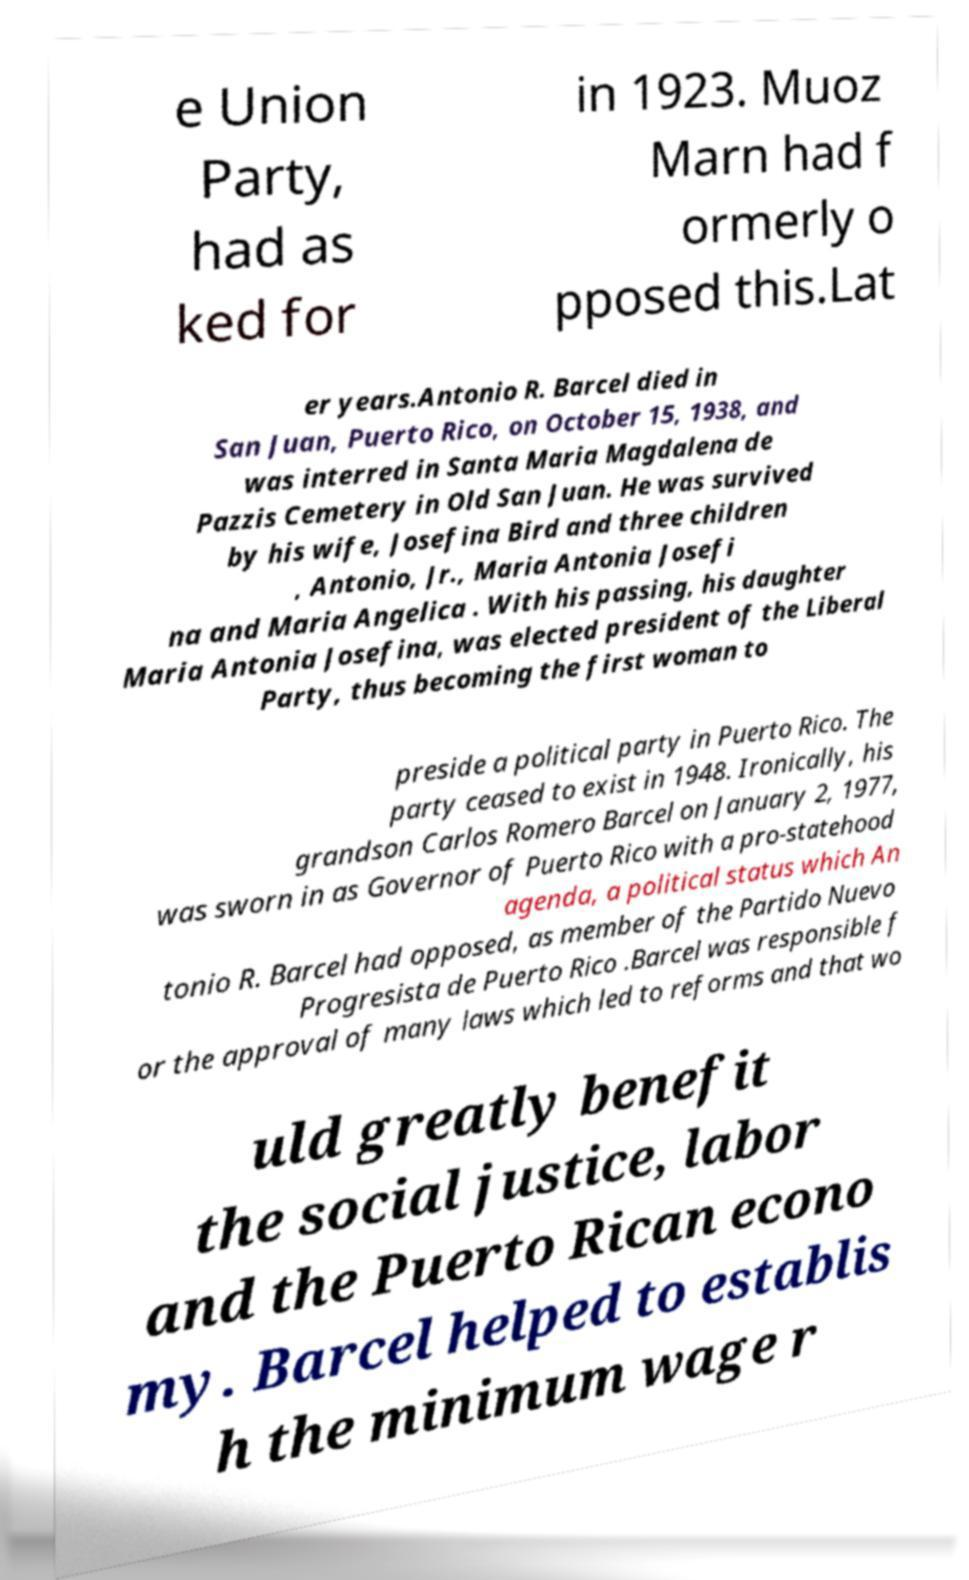Can you read and provide the text displayed in the image?This photo seems to have some interesting text. Can you extract and type it out for me? e Union Party, had as ked for in 1923. Muoz Marn had f ormerly o pposed this.Lat er years.Antonio R. Barcel died in San Juan, Puerto Rico, on October 15, 1938, and was interred in Santa Maria Magdalena de Pazzis Cemetery in Old San Juan. He was survived by his wife, Josefina Bird and three children , Antonio, Jr., Maria Antonia Josefi na and Maria Angelica . With his passing, his daughter Maria Antonia Josefina, was elected president of the Liberal Party, thus becoming the first woman to preside a political party in Puerto Rico. The party ceased to exist in 1948. Ironically, his grandson Carlos Romero Barcel on January 2, 1977, was sworn in as Governor of Puerto Rico with a pro-statehood agenda, a political status which An tonio R. Barcel had opposed, as member of the Partido Nuevo Progresista de Puerto Rico .Barcel was responsible f or the approval of many laws which led to reforms and that wo uld greatly benefit the social justice, labor and the Puerto Rican econo my. Barcel helped to establis h the minimum wage r 